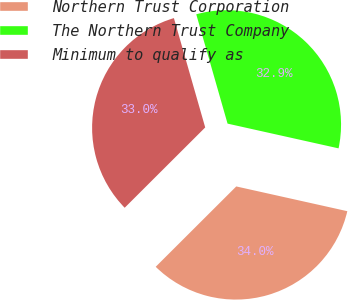Convert chart. <chart><loc_0><loc_0><loc_500><loc_500><pie_chart><fcel>Northern Trust Corporation<fcel>The Northern Trust Company<fcel>Minimum to qualify as<nl><fcel>34.03%<fcel>32.93%<fcel>33.04%<nl></chart> 